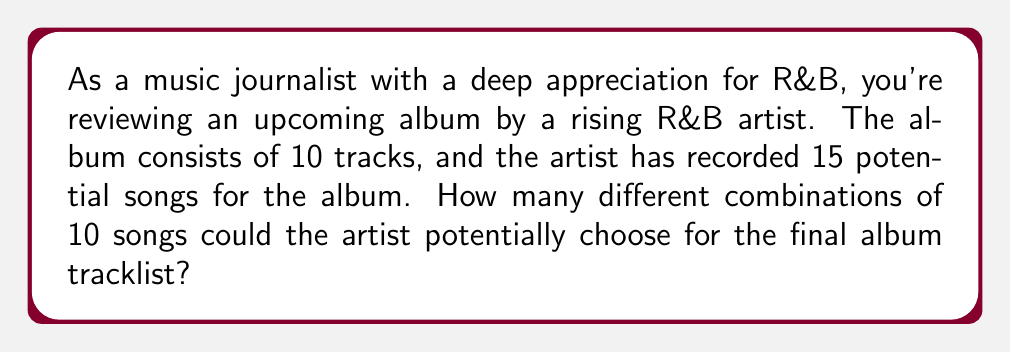Teach me how to tackle this problem. To solve this problem, we need to use the combination formula. We are selecting 10 songs out of a total of 15 songs, where the order doesn't matter (since we're just concerned with which songs are on the album, not their order).

The formula for combinations is:

$$C(n,r) = \frac{n!}{r!(n-r)!}$$

Where:
$n$ is the total number of items to choose from (in this case, 15 songs)
$r$ is the number of items being chosen (in this case, 10 songs)

Plugging in our values:

$$C(15,10) = \frac{15!}{10!(15-10)!} = \frac{15!}{10!5!}$$

Now, let's calculate this step-by-step:

1) First, expand this:
   $$\frac{15 \times 14 \times 13 \times 12 \times 11 \times 10!}{10! \times 5 \times 4 \times 3 \times 2 \times 1}$$

2) The 10! cancels out in the numerator and denominator:
   $$\frac{15 \times 14 \times 13 \times 12 \times 11}{5 \times 4 \times 3 \times 2 \times 1}$$

3) Multiply the numerator and denominator:
   $$\frac{360,360}{120}$$

4) Divide:
   $$3,003$$

Therefore, there are 3,003 possible combinations of 10 songs that could be chosen for the final album tracklist.
Answer: 3,003 possible combinations 